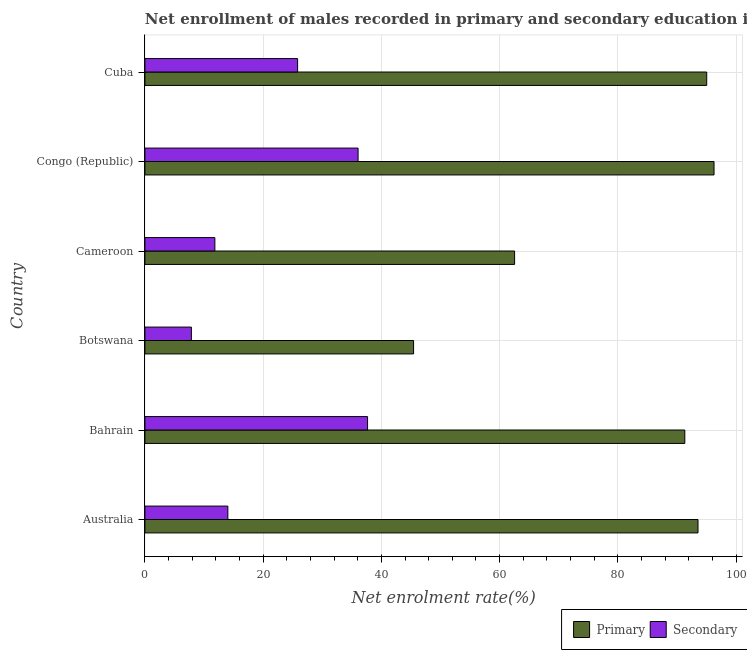How many groups of bars are there?
Provide a short and direct response. 6. Are the number of bars per tick equal to the number of legend labels?
Your answer should be very brief. Yes. How many bars are there on the 1st tick from the bottom?
Make the answer very short. 2. What is the label of the 5th group of bars from the top?
Give a very brief answer. Bahrain. What is the enrollment rate in secondary education in Cuba?
Your response must be concise. 25.83. Across all countries, what is the maximum enrollment rate in secondary education?
Give a very brief answer. 37.67. Across all countries, what is the minimum enrollment rate in secondary education?
Offer a very short reply. 7.86. In which country was the enrollment rate in secondary education maximum?
Provide a short and direct response. Bahrain. In which country was the enrollment rate in secondary education minimum?
Keep it short and to the point. Botswana. What is the total enrollment rate in primary education in the graph?
Your answer should be compact. 484.21. What is the difference between the enrollment rate in primary education in Bahrain and that in Botswana?
Make the answer very short. 45.88. What is the difference between the enrollment rate in primary education in Botswana and the enrollment rate in secondary education in Cameroon?
Your answer should be very brief. 33.62. What is the average enrollment rate in secondary education per country?
Offer a very short reply. 22.21. What is the difference between the enrollment rate in primary education and enrollment rate in secondary education in Congo (Republic)?
Offer a very short reply. 60.22. In how many countries, is the enrollment rate in primary education greater than 44 %?
Give a very brief answer. 6. What is the ratio of the enrollment rate in secondary education in Australia to that in Congo (Republic)?
Ensure brevity in your answer.  0.39. Is the difference between the enrollment rate in primary education in Bahrain and Botswana greater than the difference between the enrollment rate in secondary education in Bahrain and Botswana?
Make the answer very short. Yes. What is the difference between the highest and the second highest enrollment rate in primary education?
Provide a short and direct response. 1.24. What is the difference between the highest and the lowest enrollment rate in primary education?
Your answer should be very brief. 50.83. Is the sum of the enrollment rate in secondary education in Botswana and Congo (Republic) greater than the maximum enrollment rate in primary education across all countries?
Give a very brief answer. No. What does the 1st bar from the top in Australia represents?
Keep it short and to the point. Secondary. What does the 2nd bar from the bottom in Congo (Republic) represents?
Keep it short and to the point. Secondary. How many countries are there in the graph?
Make the answer very short. 6. Are the values on the major ticks of X-axis written in scientific E-notation?
Ensure brevity in your answer.  No. Does the graph contain any zero values?
Make the answer very short. No. Does the graph contain grids?
Keep it short and to the point. Yes. Where does the legend appear in the graph?
Your answer should be compact. Bottom right. How are the legend labels stacked?
Your answer should be compact. Horizontal. What is the title of the graph?
Give a very brief answer. Net enrollment of males recorded in primary and secondary education in year 1974. What is the label or title of the X-axis?
Offer a very short reply. Net enrolment rate(%). What is the label or title of the Y-axis?
Your response must be concise. Country. What is the Net enrolment rate(%) in Primary in Australia?
Offer a very short reply. 93.57. What is the Net enrolment rate(%) of Secondary in Australia?
Ensure brevity in your answer.  14.03. What is the Net enrolment rate(%) of Primary in Bahrain?
Offer a very short reply. 91.34. What is the Net enrolment rate(%) in Secondary in Bahrain?
Keep it short and to the point. 37.67. What is the Net enrolment rate(%) of Primary in Botswana?
Your answer should be compact. 45.45. What is the Net enrolment rate(%) of Secondary in Botswana?
Make the answer very short. 7.86. What is the Net enrolment rate(%) in Primary in Cameroon?
Offer a very short reply. 62.54. What is the Net enrolment rate(%) of Secondary in Cameroon?
Give a very brief answer. 11.84. What is the Net enrolment rate(%) in Primary in Congo (Republic)?
Your response must be concise. 96.28. What is the Net enrolment rate(%) of Secondary in Congo (Republic)?
Provide a succinct answer. 36.06. What is the Net enrolment rate(%) of Primary in Cuba?
Provide a short and direct response. 95.04. What is the Net enrolment rate(%) in Secondary in Cuba?
Offer a very short reply. 25.83. Across all countries, what is the maximum Net enrolment rate(%) of Primary?
Give a very brief answer. 96.28. Across all countries, what is the maximum Net enrolment rate(%) in Secondary?
Keep it short and to the point. 37.67. Across all countries, what is the minimum Net enrolment rate(%) in Primary?
Offer a very short reply. 45.45. Across all countries, what is the minimum Net enrolment rate(%) of Secondary?
Provide a short and direct response. 7.86. What is the total Net enrolment rate(%) of Primary in the graph?
Offer a very short reply. 484.21. What is the total Net enrolment rate(%) in Secondary in the graph?
Your answer should be compact. 133.28. What is the difference between the Net enrolment rate(%) of Primary in Australia and that in Bahrain?
Keep it short and to the point. 2.23. What is the difference between the Net enrolment rate(%) in Secondary in Australia and that in Bahrain?
Your answer should be very brief. -23.63. What is the difference between the Net enrolment rate(%) of Primary in Australia and that in Botswana?
Give a very brief answer. 48.12. What is the difference between the Net enrolment rate(%) of Secondary in Australia and that in Botswana?
Make the answer very short. 6.17. What is the difference between the Net enrolment rate(%) of Primary in Australia and that in Cameroon?
Your answer should be compact. 31.03. What is the difference between the Net enrolment rate(%) in Secondary in Australia and that in Cameroon?
Give a very brief answer. 2.2. What is the difference between the Net enrolment rate(%) in Primary in Australia and that in Congo (Republic)?
Your response must be concise. -2.71. What is the difference between the Net enrolment rate(%) of Secondary in Australia and that in Congo (Republic)?
Provide a succinct answer. -22.03. What is the difference between the Net enrolment rate(%) of Primary in Australia and that in Cuba?
Offer a terse response. -1.48. What is the difference between the Net enrolment rate(%) in Secondary in Australia and that in Cuba?
Provide a succinct answer. -11.8. What is the difference between the Net enrolment rate(%) in Primary in Bahrain and that in Botswana?
Your answer should be very brief. 45.88. What is the difference between the Net enrolment rate(%) in Secondary in Bahrain and that in Botswana?
Your answer should be compact. 29.81. What is the difference between the Net enrolment rate(%) of Primary in Bahrain and that in Cameroon?
Your answer should be very brief. 28.8. What is the difference between the Net enrolment rate(%) in Secondary in Bahrain and that in Cameroon?
Your answer should be very brief. 25.83. What is the difference between the Net enrolment rate(%) of Primary in Bahrain and that in Congo (Republic)?
Your response must be concise. -4.94. What is the difference between the Net enrolment rate(%) in Secondary in Bahrain and that in Congo (Republic)?
Your response must be concise. 1.6. What is the difference between the Net enrolment rate(%) in Primary in Bahrain and that in Cuba?
Make the answer very short. -3.71. What is the difference between the Net enrolment rate(%) in Secondary in Bahrain and that in Cuba?
Offer a terse response. 11.84. What is the difference between the Net enrolment rate(%) of Primary in Botswana and that in Cameroon?
Make the answer very short. -17.09. What is the difference between the Net enrolment rate(%) in Secondary in Botswana and that in Cameroon?
Keep it short and to the point. -3.98. What is the difference between the Net enrolment rate(%) of Primary in Botswana and that in Congo (Republic)?
Offer a very short reply. -50.83. What is the difference between the Net enrolment rate(%) of Secondary in Botswana and that in Congo (Republic)?
Your answer should be compact. -28.2. What is the difference between the Net enrolment rate(%) in Primary in Botswana and that in Cuba?
Give a very brief answer. -49.59. What is the difference between the Net enrolment rate(%) in Secondary in Botswana and that in Cuba?
Offer a terse response. -17.97. What is the difference between the Net enrolment rate(%) in Primary in Cameroon and that in Congo (Republic)?
Offer a very short reply. -33.74. What is the difference between the Net enrolment rate(%) in Secondary in Cameroon and that in Congo (Republic)?
Your answer should be compact. -24.23. What is the difference between the Net enrolment rate(%) of Primary in Cameroon and that in Cuba?
Your answer should be compact. -32.5. What is the difference between the Net enrolment rate(%) of Secondary in Cameroon and that in Cuba?
Provide a succinct answer. -13.99. What is the difference between the Net enrolment rate(%) of Primary in Congo (Republic) and that in Cuba?
Your response must be concise. 1.24. What is the difference between the Net enrolment rate(%) of Secondary in Congo (Republic) and that in Cuba?
Make the answer very short. 10.23. What is the difference between the Net enrolment rate(%) of Primary in Australia and the Net enrolment rate(%) of Secondary in Bahrain?
Offer a very short reply. 55.9. What is the difference between the Net enrolment rate(%) in Primary in Australia and the Net enrolment rate(%) in Secondary in Botswana?
Give a very brief answer. 85.71. What is the difference between the Net enrolment rate(%) in Primary in Australia and the Net enrolment rate(%) in Secondary in Cameroon?
Make the answer very short. 81.73. What is the difference between the Net enrolment rate(%) of Primary in Australia and the Net enrolment rate(%) of Secondary in Congo (Republic)?
Give a very brief answer. 57.51. What is the difference between the Net enrolment rate(%) in Primary in Australia and the Net enrolment rate(%) in Secondary in Cuba?
Provide a short and direct response. 67.74. What is the difference between the Net enrolment rate(%) in Primary in Bahrain and the Net enrolment rate(%) in Secondary in Botswana?
Provide a succinct answer. 83.48. What is the difference between the Net enrolment rate(%) in Primary in Bahrain and the Net enrolment rate(%) in Secondary in Cameroon?
Provide a succinct answer. 79.5. What is the difference between the Net enrolment rate(%) of Primary in Bahrain and the Net enrolment rate(%) of Secondary in Congo (Republic)?
Provide a succinct answer. 55.27. What is the difference between the Net enrolment rate(%) in Primary in Bahrain and the Net enrolment rate(%) in Secondary in Cuba?
Your response must be concise. 65.51. What is the difference between the Net enrolment rate(%) in Primary in Botswana and the Net enrolment rate(%) in Secondary in Cameroon?
Make the answer very short. 33.62. What is the difference between the Net enrolment rate(%) in Primary in Botswana and the Net enrolment rate(%) in Secondary in Congo (Republic)?
Keep it short and to the point. 9.39. What is the difference between the Net enrolment rate(%) in Primary in Botswana and the Net enrolment rate(%) in Secondary in Cuba?
Offer a very short reply. 19.62. What is the difference between the Net enrolment rate(%) of Primary in Cameroon and the Net enrolment rate(%) of Secondary in Congo (Republic)?
Provide a succinct answer. 26.48. What is the difference between the Net enrolment rate(%) of Primary in Cameroon and the Net enrolment rate(%) of Secondary in Cuba?
Your answer should be very brief. 36.71. What is the difference between the Net enrolment rate(%) in Primary in Congo (Republic) and the Net enrolment rate(%) in Secondary in Cuba?
Provide a succinct answer. 70.45. What is the average Net enrolment rate(%) of Primary per country?
Your answer should be compact. 80.7. What is the average Net enrolment rate(%) in Secondary per country?
Provide a short and direct response. 22.21. What is the difference between the Net enrolment rate(%) of Primary and Net enrolment rate(%) of Secondary in Australia?
Your answer should be very brief. 79.53. What is the difference between the Net enrolment rate(%) in Primary and Net enrolment rate(%) in Secondary in Bahrain?
Provide a short and direct response. 53.67. What is the difference between the Net enrolment rate(%) of Primary and Net enrolment rate(%) of Secondary in Botswana?
Your answer should be very brief. 37.59. What is the difference between the Net enrolment rate(%) in Primary and Net enrolment rate(%) in Secondary in Cameroon?
Make the answer very short. 50.7. What is the difference between the Net enrolment rate(%) in Primary and Net enrolment rate(%) in Secondary in Congo (Republic)?
Ensure brevity in your answer.  60.22. What is the difference between the Net enrolment rate(%) in Primary and Net enrolment rate(%) in Secondary in Cuba?
Your answer should be compact. 69.21. What is the ratio of the Net enrolment rate(%) in Primary in Australia to that in Bahrain?
Ensure brevity in your answer.  1.02. What is the ratio of the Net enrolment rate(%) of Secondary in Australia to that in Bahrain?
Provide a succinct answer. 0.37. What is the ratio of the Net enrolment rate(%) of Primary in Australia to that in Botswana?
Make the answer very short. 2.06. What is the ratio of the Net enrolment rate(%) in Secondary in Australia to that in Botswana?
Make the answer very short. 1.79. What is the ratio of the Net enrolment rate(%) of Primary in Australia to that in Cameroon?
Ensure brevity in your answer.  1.5. What is the ratio of the Net enrolment rate(%) of Secondary in Australia to that in Cameroon?
Ensure brevity in your answer.  1.19. What is the ratio of the Net enrolment rate(%) of Primary in Australia to that in Congo (Republic)?
Provide a short and direct response. 0.97. What is the ratio of the Net enrolment rate(%) of Secondary in Australia to that in Congo (Republic)?
Keep it short and to the point. 0.39. What is the ratio of the Net enrolment rate(%) in Primary in Australia to that in Cuba?
Your answer should be very brief. 0.98. What is the ratio of the Net enrolment rate(%) of Secondary in Australia to that in Cuba?
Provide a succinct answer. 0.54. What is the ratio of the Net enrolment rate(%) in Primary in Bahrain to that in Botswana?
Make the answer very short. 2.01. What is the ratio of the Net enrolment rate(%) of Secondary in Bahrain to that in Botswana?
Offer a very short reply. 4.79. What is the ratio of the Net enrolment rate(%) of Primary in Bahrain to that in Cameroon?
Offer a very short reply. 1.46. What is the ratio of the Net enrolment rate(%) in Secondary in Bahrain to that in Cameroon?
Your answer should be very brief. 3.18. What is the ratio of the Net enrolment rate(%) in Primary in Bahrain to that in Congo (Republic)?
Your answer should be very brief. 0.95. What is the ratio of the Net enrolment rate(%) of Secondary in Bahrain to that in Congo (Republic)?
Make the answer very short. 1.04. What is the ratio of the Net enrolment rate(%) in Secondary in Bahrain to that in Cuba?
Offer a terse response. 1.46. What is the ratio of the Net enrolment rate(%) of Primary in Botswana to that in Cameroon?
Your answer should be very brief. 0.73. What is the ratio of the Net enrolment rate(%) of Secondary in Botswana to that in Cameroon?
Keep it short and to the point. 0.66. What is the ratio of the Net enrolment rate(%) of Primary in Botswana to that in Congo (Republic)?
Provide a succinct answer. 0.47. What is the ratio of the Net enrolment rate(%) of Secondary in Botswana to that in Congo (Republic)?
Offer a terse response. 0.22. What is the ratio of the Net enrolment rate(%) in Primary in Botswana to that in Cuba?
Offer a very short reply. 0.48. What is the ratio of the Net enrolment rate(%) in Secondary in Botswana to that in Cuba?
Your response must be concise. 0.3. What is the ratio of the Net enrolment rate(%) of Primary in Cameroon to that in Congo (Republic)?
Your answer should be compact. 0.65. What is the ratio of the Net enrolment rate(%) of Secondary in Cameroon to that in Congo (Republic)?
Your answer should be compact. 0.33. What is the ratio of the Net enrolment rate(%) of Primary in Cameroon to that in Cuba?
Your response must be concise. 0.66. What is the ratio of the Net enrolment rate(%) of Secondary in Cameroon to that in Cuba?
Give a very brief answer. 0.46. What is the ratio of the Net enrolment rate(%) in Secondary in Congo (Republic) to that in Cuba?
Provide a succinct answer. 1.4. What is the difference between the highest and the second highest Net enrolment rate(%) in Primary?
Your answer should be compact. 1.24. What is the difference between the highest and the second highest Net enrolment rate(%) in Secondary?
Keep it short and to the point. 1.6. What is the difference between the highest and the lowest Net enrolment rate(%) of Primary?
Provide a succinct answer. 50.83. What is the difference between the highest and the lowest Net enrolment rate(%) in Secondary?
Ensure brevity in your answer.  29.81. 